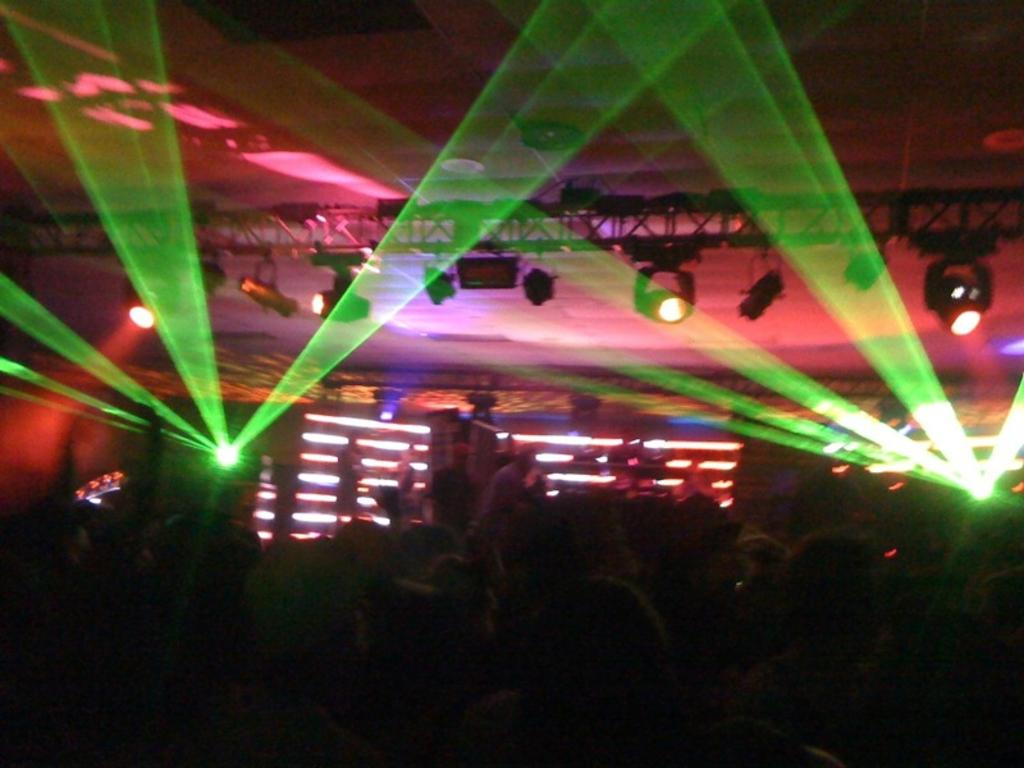How many people are in the image? There is a group of people in the image. What are some of the people in the image doing? Some people are standing on a stage in the background. What can be seen in the image that provides illumination? There are lights visible in the image. What type of structure is present in the image? There is a roof in the image. How many cats are jumping on the stage in the image? There are no cats present in the image, and no one is jumping on the stage. 